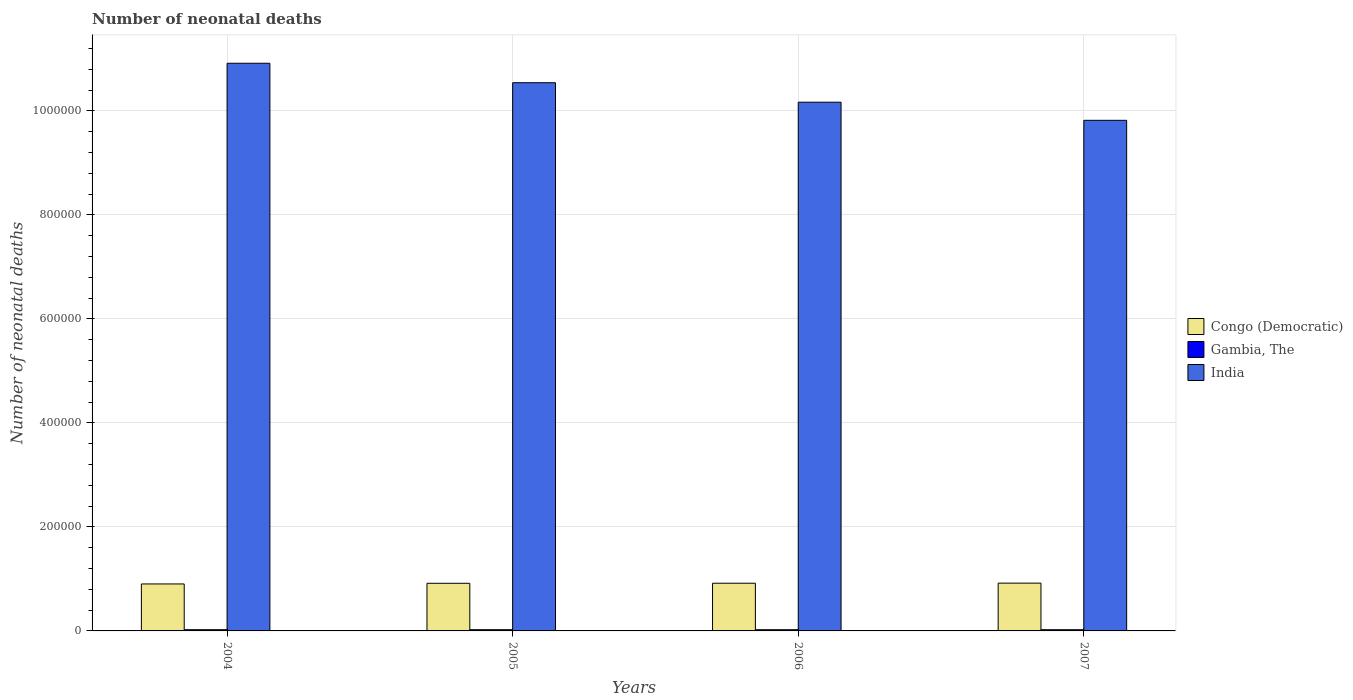How many different coloured bars are there?
Offer a very short reply. 3. How many groups of bars are there?
Keep it short and to the point. 4. Are the number of bars per tick equal to the number of legend labels?
Make the answer very short. Yes. Are the number of bars on each tick of the X-axis equal?
Give a very brief answer. Yes. How many bars are there on the 4th tick from the left?
Offer a terse response. 3. How many bars are there on the 4th tick from the right?
Your answer should be very brief. 3. What is the label of the 2nd group of bars from the left?
Give a very brief answer. 2005. What is the number of neonatal deaths in in India in 2007?
Your answer should be compact. 9.82e+05. Across all years, what is the maximum number of neonatal deaths in in Congo (Democratic)?
Your answer should be very brief. 9.19e+04. Across all years, what is the minimum number of neonatal deaths in in Congo (Democratic)?
Your response must be concise. 9.03e+04. In which year was the number of neonatal deaths in in Gambia, The maximum?
Make the answer very short. 2004. What is the total number of neonatal deaths in in Gambia, The in the graph?
Offer a very short reply. 9248. What is the difference between the number of neonatal deaths in in Gambia, The in 2005 and that in 2007?
Your response must be concise. 2. What is the difference between the number of neonatal deaths in in Gambia, The in 2007 and the number of neonatal deaths in in Congo (Democratic) in 2006?
Your answer should be very brief. -8.94e+04. What is the average number of neonatal deaths in in Gambia, The per year?
Your answer should be compact. 2312. In the year 2007, what is the difference between the number of neonatal deaths in in India and number of neonatal deaths in in Congo (Democratic)?
Ensure brevity in your answer.  8.90e+05. What is the ratio of the number of neonatal deaths in in Congo (Democratic) in 2005 to that in 2007?
Offer a very short reply. 1. What is the difference between the highest and the second highest number of neonatal deaths in in Congo (Democratic)?
Provide a short and direct response. 199. What is the difference between the highest and the lowest number of neonatal deaths in in India?
Provide a succinct answer. 1.10e+05. What does the 1st bar from the left in 2006 represents?
Ensure brevity in your answer.  Congo (Democratic). What does the 2nd bar from the right in 2004 represents?
Your response must be concise. Gambia, The. Does the graph contain any zero values?
Your answer should be very brief. No. Does the graph contain grids?
Offer a terse response. Yes. Where does the legend appear in the graph?
Ensure brevity in your answer.  Center right. How many legend labels are there?
Give a very brief answer. 3. What is the title of the graph?
Offer a terse response. Number of neonatal deaths. What is the label or title of the X-axis?
Give a very brief answer. Years. What is the label or title of the Y-axis?
Ensure brevity in your answer.  Number of neonatal deaths. What is the Number of neonatal deaths of Congo (Democratic) in 2004?
Your response must be concise. 9.03e+04. What is the Number of neonatal deaths in Gambia, The in 2004?
Provide a succinct answer. 2315. What is the Number of neonatal deaths in India in 2004?
Your answer should be very brief. 1.09e+06. What is the Number of neonatal deaths in Congo (Democratic) in 2005?
Provide a short and direct response. 9.16e+04. What is the Number of neonatal deaths in Gambia, The in 2005?
Provide a succinct answer. 2314. What is the Number of neonatal deaths of India in 2005?
Your response must be concise. 1.05e+06. What is the Number of neonatal deaths of Congo (Democratic) in 2006?
Provide a short and direct response. 9.17e+04. What is the Number of neonatal deaths of Gambia, The in 2006?
Provide a succinct answer. 2307. What is the Number of neonatal deaths of India in 2006?
Your answer should be very brief. 1.02e+06. What is the Number of neonatal deaths in Congo (Democratic) in 2007?
Your answer should be compact. 9.19e+04. What is the Number of neonatal deaths of Gambia, The in 2007?
Keep it short and to the point. 2312. What is the Number of neonatal deaths of India in 2007?
Ensure brevity in your answer.  9.82e+05. Across all years, what is the maximum Number of neonatal deaths of Congo (Democratic)?
Give a very brief answer. 9.19e+04. Across all years, what is the maximum Number of neonatal deaths of Gambia, The?
Your response must be concise. 2315. Across all years, what is the maximum Number of neonatal deaths in India?
Provide a short and direct response. 1.09e+06. Across all years, what is the minimum Number of neonatal deaths in Congo (Democratic)?
Your answer should be very brief. 9.03e+04. Across all years, what is the minimum Number of neonatal deaths in Gambia, The?
Give a very brief answer. 2307. Across all years, what is the minimum Number of neonatal deaths in India?
Keep it short and to the point. 9.82e+05. What is the total Number of neonatal deaths in Congo (Democratic) in the graph?
Make the answer very short. 3.66e+05. What is the total Number of neonatal deaths of Gambia, The in the graph?
Your response must be concise. 9248. What is the total Number of neonatal deaths of India in the graph?
Make the answer very short. 4.14e+06. What is the difference between the Number of neonatal deaths of Congo (Democratic) in 2004 and that in 2005?
Offer a terse response. -1280. What is the difference between the Number of neonatal deaths in India in 2004 and that in 2005?
Give a very brief answer. 3.74e+04. What is the difference between the Number of neonatal deaths of Congo (Democratic) in 2004 and that in 2006?
Offer a very short reply. -1382. What is the difference between the Number of neonatal deaths in India in 2004 and that in 2006?
Provide a short and direct response. 7.49e+04. What is the difference between the Number of neonatal deaths of Congo (Democratic) in 2004 and that in 2007?
Provide a succinct answer. -1581. What is the difference between the Number of neonatal deaths in India in 2004 and that in 2007?
Provide a succinct answer. 1.10e+05. What is the difference between the Number of neonatal deaths in Congo (Democratic) in 2005 and that in 2006?
Make the answer very short. -102. What is the difference between the Number of neonatal deaths of India in 2005 and that in 2006?
Your answer should be very brief. 3.75e+04. What is the difference between the Number of neonatal deaths in Congo (Democratic) in 2005 and that in 2007?
Your answer should be compact. -301. What is the difference between the Number of neonatal deaths in Gambia, The in 2005 and that in 2007?
Your response must be concise. 2. What is the difference between the Number of neonatal deaths of India in 2005 and that in 2007?
Offer a terse response. 7.23e+04. What is the difference between the Number of neonatal deaths of Congo (Democratic) in 2006 and that in 2007?
Offer a very short reply. -199. What is the difference between the Number of neonatal deaths of India in 2006 and that in 2007?
Your answer should be very brief. 3.48e+04. What is the difference between the Number of neonatal deaths of Congo (Democratic) in 2004 and the Number of neonatal deaths of Gambia, The in 2005?
Ensure brevity in your answer.  8.80e+04. What is the difference between the Number of neonatal deaths of Congo (Democratic) in 2004 and the Number of neonatal deaths of India in 2005?
Ensure brevity in your answer.  -9.64e+05. What is the difference between the Number of neonatal deaths in Gambia, The in 2004 and the Number of neonatal deaths in India in 2005?
Keep it short and to the point. -1.05e+06. What is the difference between the Number of neonatal deaths of Congo (Democratic) in 2004 and the Number of neonatal deaths of Gambia, The in 2006?
Your response must be concise. 8.80e+04. What is the difference between the Number of neonatal deaths of Congo (Democratic) in 2004 and the Number of neonatal deaths of India in 2006?
Ensure brevity in your answer.  -9.26e+05. What is the difference between the Number of neonatal deaths in Gambia, The in 2004 and the Number of neonatal deaths in India in 2006?
Offer a very short reply. -1.01e+06. What is the difference between the Number of neonatal deaths in Congo (Democratic) in 2004 and the Number of neonatal deaths in Gambia, The in 2007?
Your answer should be compact. 8.80e+04. What is the difference between the Number of neonatal deaths of Congo (Democratic) in 2004 and the Number of neonatal deaths of India in 2007?
Your answer should be very brief. -8.91e+05. What is the difference between the Number of neonatal deaths in Gambia, The in 2004 and the Number of neonatal deaths in India in 2007?
Your answer should be compact. -9.79e+05. What is the difference between the Number of neonatal deaths of Congo (Democratic) in 2005 and the Number of neonatal deaths of Gambia, The in 2006?
Provide a short and direct response. 8.93e+04. What is the difference between the Number of neonatal deaths in Congo (Democratic) in 2005 and the Number of neonatal deaths in India in 2006?
Make the answer very short. -9.25e+05. What is the difference between the Number of neonatal deaths of Gambia, The in 2005 and the Number of neonatal deaths of India in 2006?
Give a very brief answer. -1.01e+06. What is the difference between the Number of neonatal deaths in Congo (Democratic) in 2005 and the Number of neonatal deaths in Gambia, The in 2007?
Your answer should be very brief. 8.93e+04. What is the difference between the Number of neonatal deaths in Congo (Democratic) in 2005 and the Number of neonatal deaths in India in 2007?
Offer a terse response. -8.90e+05. What is the difference between the Number of neonatal deaths of Gambia, The in 2005 and the Number of neonatal deaths of India in 2007?
Provide a short and direct response. -9.79e+05. What is the difference between the Number of neonatal deaths of Congo (Democratic) in 2006 and the Number of neonatal deaths of Gambia, The in 2007?
Keep it short and to the point. 8.94e+04. What is the difference between the Number of neonatal deaths of Congo (Democratic) in 2006 and the Number of neonatal deaths of India in 2007?
Keep it short and to the point. -8.90e+05. What is the difference between the Number of neonatal deaths of Gambia, The in 2006 and the Number of neonatal deaths of India in 2007?
Offer a very short reply. -9.80e+05. What is the average Number of neonatal deaths of Congo (Democratic) per year?
Provide a short and direct response. 9.14e+04. What is the average Number of neonatal deaths of Gambia, The per year?
Your response must be concise. 2312. What is the average Number of neonatal deaths of India per year?
Provide a short and direct response. 1.04e+06. In the year 2004, what is the difference between the Number of neonatal deaths in Congo (Democratic) and Number of neonatal deaths in Gambia, The?
Make the answer very short. 8.80e+04. In the year 2004, what is the difference between the Number of neonatal deaths in Congo (Democratic) and Number of neonatal deaths in India?
Offer a very short reply. -1.00e+06. In the year 2004, what is the difference between the Number of neonatal deaths in Gambia, The and Number of neonatal deaths in India?
Provide a succinct answer. -1.09e+06. In the year 2005, what is the difference between the Number of neonatal deaths in Congo (Democratic) and Number of neonatal deaths in Gambia, The?
Provide a short and direct response. 8.93e+04. In the year 2005, what is the difference between the Number of neonatal deaths in Congo (Democratic) and Number of neonatal deaths in India?
Give a very brief answer. -9.63e+05. In the year 2005, what is the difference between the Number of neonatal deaths of Gambia, The and Number of neonatal deaths of India?
Provide a short and direct response. -1.05e+06. In the year 2006, what is the difference between the Number of neonatal deaths of Congo (Democratic) and Number of neonatal deaths of Gambia, The?
Provide a succinct answer. 8.94e+04. In the year 2006, what is the difference between the Number of neonatal deaths in Congo (Democratic) and Number of neonatal deaths in India?
Make the answer very short. -9.25e+05. In the year 2006, what is the difference between the Number of neonatal deaths of Gambia, The and Number of neonatal deaths of India?
Provide a short and direct response. -1.01e+06. In the year 2007, what is the difference between the Number of neonatal deaths in Congo (Democratic) and Number of neonatal deaths in Gambia, The?
Your answer should be very brief. 8.96e+04. In the year 2007, what is the difference between the Number of neonatal deaths in Congo (Democratic) and Number of neonatal deaths in India?
Your answer should be compact. -8.90e+05. In the year 2007, what is the difference between the Number of neonatal deaths of Gambia, The and Number of neonatal deaths of India?
Offer a terse response. -9.79e+05. What is the ratio of the Number of neonatal deaths in Congo (Democratic) in 2004 to that in 2005?
Keep it short and to the point. 0.99. What is the ratio of the Number of neonatal deaths in Gambia, The in 2004 to that in 2005?
Make the answer very short. 1. What is the ratio of the Number of neonatal deaths in India in 2004 to that in 2005?
Your answer should be very brief. 1.04. What is the ratio of the Number of neonatal deaths of Congo (Democratic) in 2004 to that in 2006?
Offer a very short reply. 0.98. What is the ratio of the Number of neonatal deaths in Gambia, The in 2004 to that in 2006?
Keep it short and to the point. 1. What is the ratio of the Number of neonatal deaths of India in 2004 to that in 2006?
Your answer should be compact. 1.07. What is the ratio of the Number of neonatal deaths in Congo (Democratic) in 2004 to that in 2007?
Keep it short and to the point. 0.98. What is the ratio of the Number of neonatal deaths in Gambia, The in 2004 to that in 2007?
Your answer should be very brief. 1. What is the ratio of the Number of neonatal deaths in India in 2004 to that in 2007?
Your answer should be very brief. 1.11. What is the ratio of the Number of neonatal deaths of Congo (Democratic) in 2005 to that in 2006?
Your answer should be compact. 1. What is the ratio of the Number of neonatal deaths of Gambia, The in 2005 to that in 2006?
Provide a short and direct response. 1. What is the ratio of the Number of neonatal deaths of India in 2005 to that in 2006?
Keep it short and to the point. 1.04. What is the ratio of the Number of neonatal deaths of Congo (Democratic) in 2005 to that in 2007?
Make the answer very short. 1. What is the ratio of the Number of neonatal deaths in Gambia, The in 2005 to that in 2007?
Offer a terse response. 1. What is the ratio of the Number of neonatal deaths in India in 2005 to that in 2007?
Provide a short and direct response. 1.07. What is the ratio of the Number of neonatal deaths in Congo (Democratic) in 2006 to that in 2007?
Keep it short and to the point. 1. What is the ratio of the Number of neonatal deaths in India in 2006 to that in 2007?
Your answer should be compact. 1.04. What is the difference between the highest and the second highest Number of neonatal deaths of Congo (Democratic)?
Ensure brevity in your answer.  199. What is the difference between the highest and the second highest Number of neonatal deaths of India?
Provide a succinct answer. 3.74e+04. What is the difference between the highest and the lowest Number of neonatal deaths in Congo (Democratic)?
Give a very brief answer. 1581. What is the difference between the highest and the lowest Number of neonatal deaths of Gambia, The?
Your response must be concise. 8. What is the difference between the highest and the lowest Number of neonatal deaths of India?
Provide a succinct answer. 1.10e+05. 